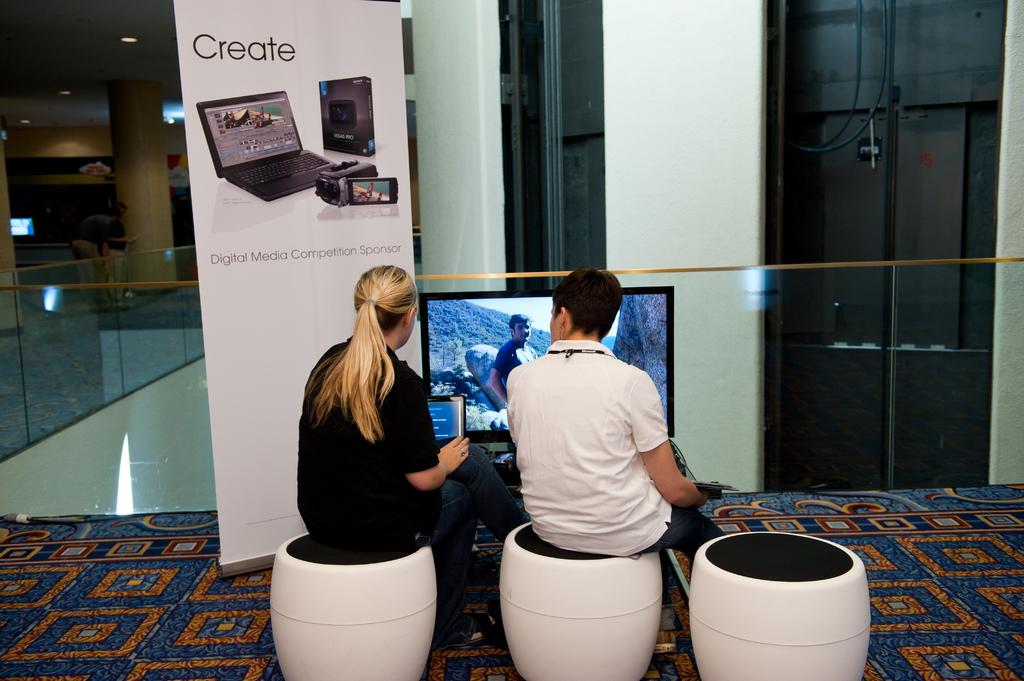Who is the digital media competition sponsor?
Offer a terse response. Create. What does it say on the white poster?
Provide a succinct answer. Create. 